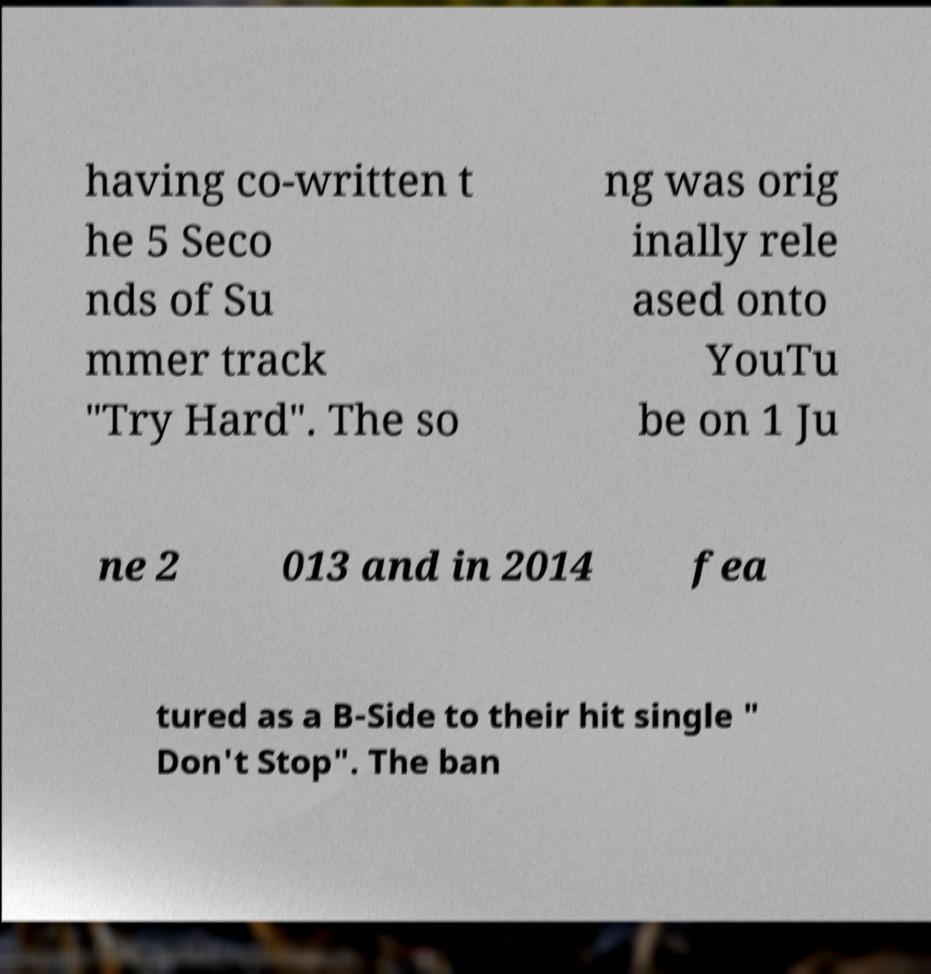For documentation purposes, I need the text within this image transcribed. Could you provide that? having co-written t he 5 Seco nds of Su mmer track "Try Hard". The so ng was orig inally rele ased onto YouTu be on 1 Ju ne 2 013 and in 2014 fea tured as a B-Side to their hit single " Don't Stop". The ban 